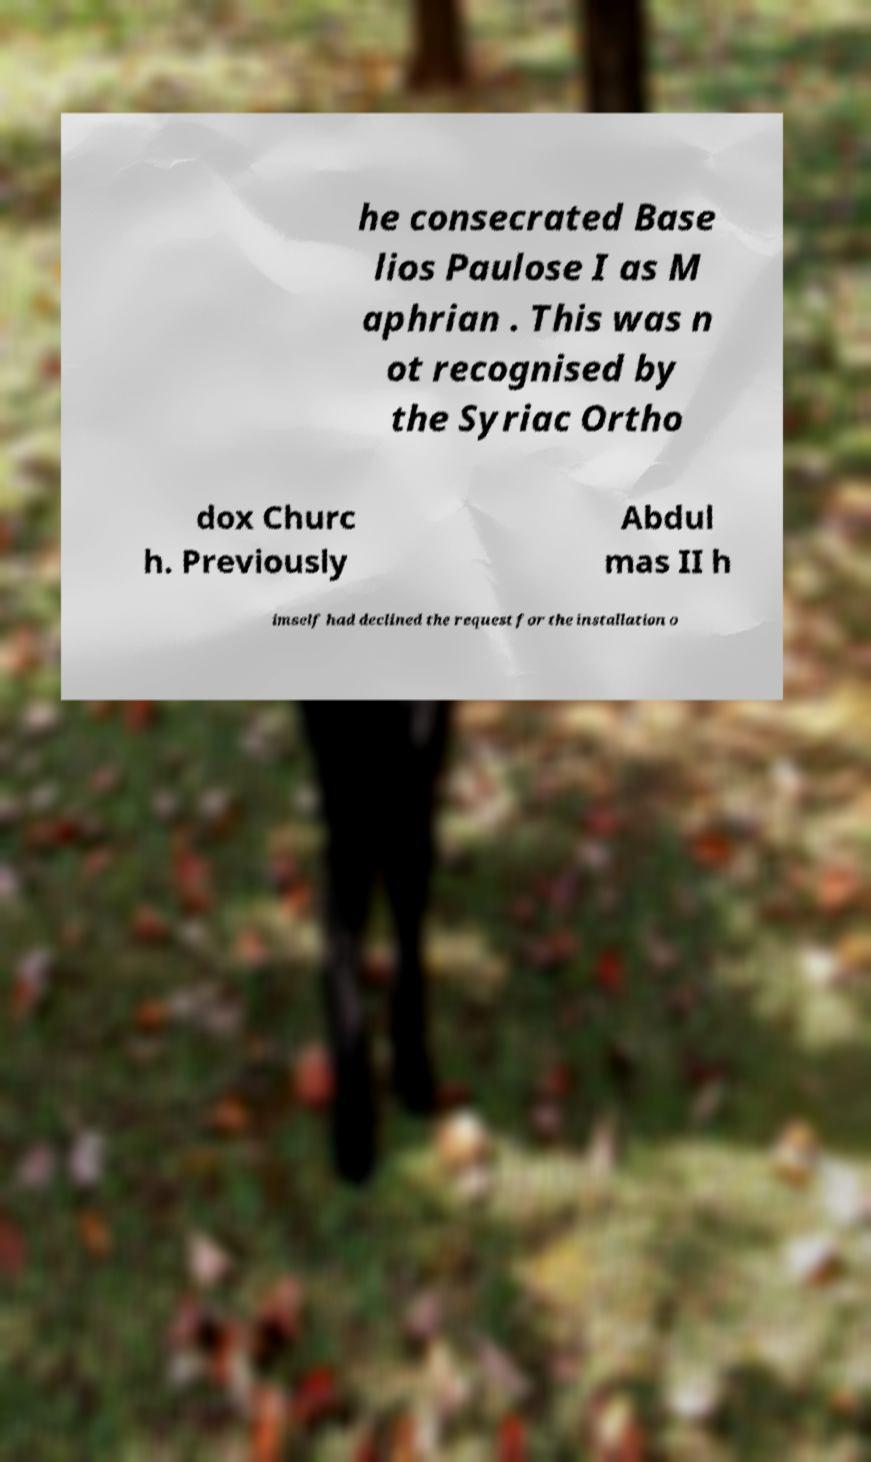There's text embedded in this image that I need extracted. Can you transcribe it verbatim? he consecrated Base lios Paulose I as M aphrian . This was n ot recognised by the Syriac Ortho dox Churc h. Previously Abdul mas II h imself had declined the request for the installation o 